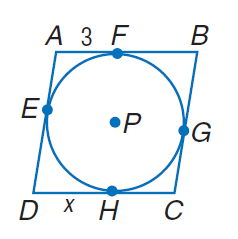Answer the mathemtical geometry problem and directly provide the correct option letter.
Question: Rhombus A B C D is circumscribed about \odot P and has a perimeter of 32. Find x.
Choices: A: 3 B: 4 C: 5 D: 6 C 